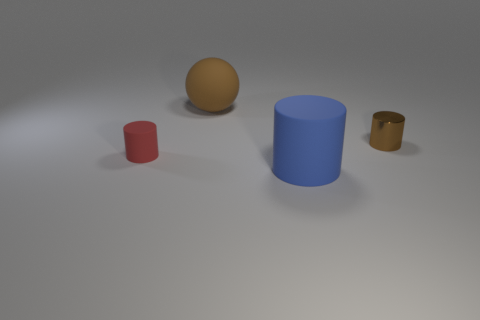Are there any other things that have the same shape as the large brown object?
Offer a very short reply. No. Are there fewer brown matte things in front of the sphere than objects behind the large blue cylinder?
Provide a succinct answer. Yes. What color is the rubber sphere?
Your response must be concise. Brown. What number of matte objects have the same color as the sphere?
Your response must be concise. 0. Are there any balls in front of the small red cylinder?
Make the answer very short. No. Are there the same number of red objects in front of the tiny brown object and brown spheres that are behind the small red rubber cylinder?
Provide a succinct answer. Yes. Does the blue cylinder that is in front of the rubber ball have the same size as the cylinder behind the red rubber cylinder?
Provide a succinct answer. No. The object on the left side of the big brown matte sphere that is to the right of the rubber thing that is on the left side of the brown rubber ball is what shape?
Give a very brief answer. Cylinder. Is there any other thing that is the same material as the tiny brown object?
Your response must be concise. No. What size is the blue matte thing that is the same shape as the small brown object?
Your response must be concise. Large. 